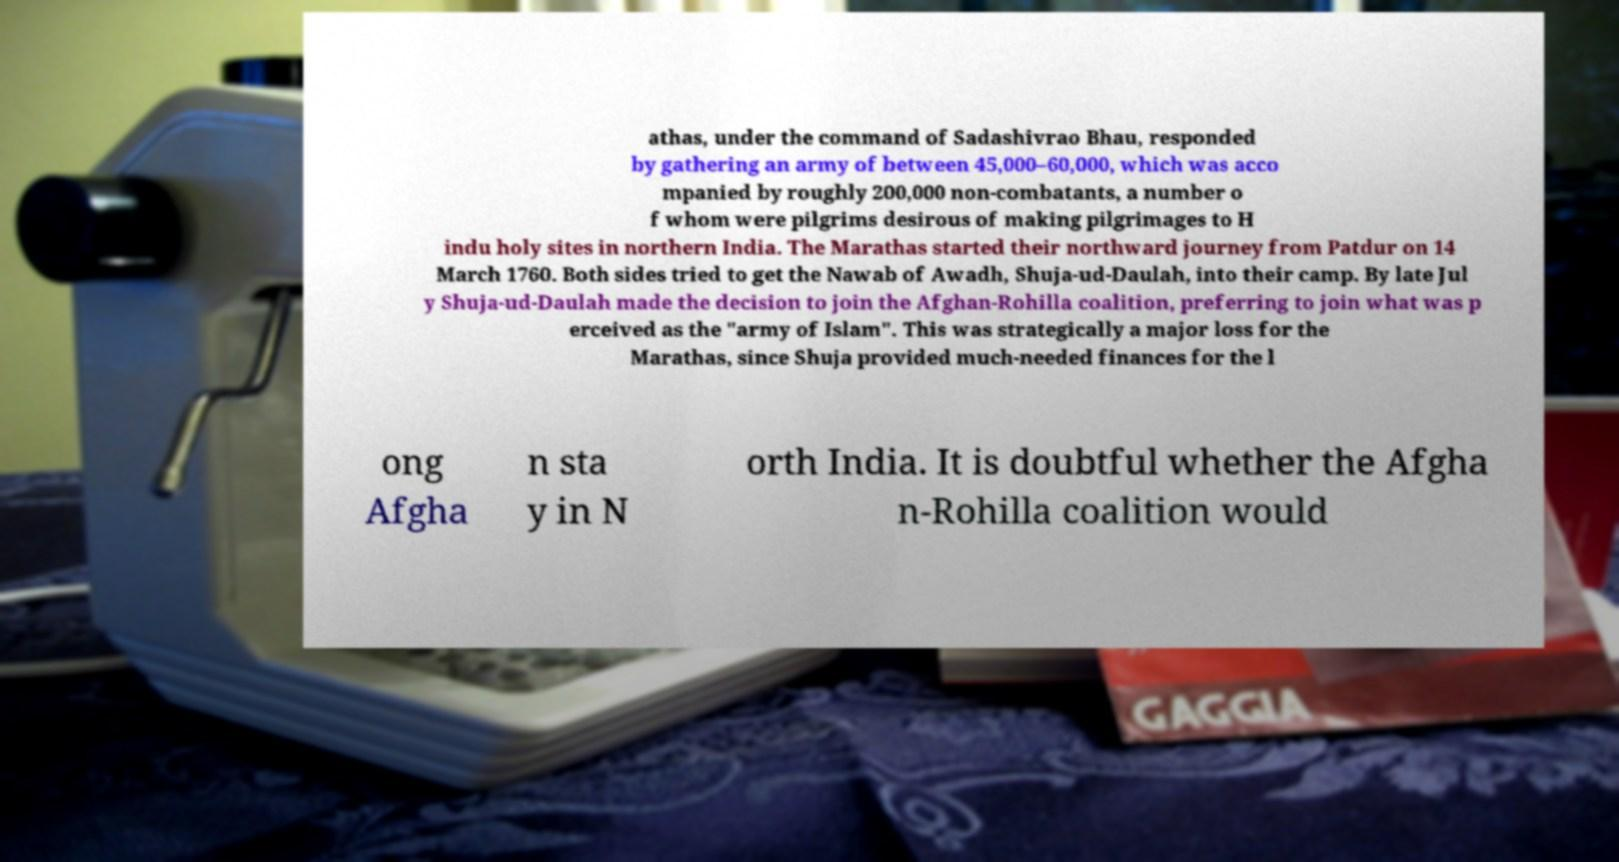Can you accurately transcribe the text from the provided image for me? athas, under the command of Sadashivrao Bhau, responded by gathering an army of between 45,000–60,000, which was acco mpanied by roughly 200,000 non-combatants, a number o f whom were pilgrims desirous of making pilgrimages to H indu holy sites in northern India. The Marathas started their northward journey from Patdur on 14 March 1760. Both sides tried to get the Nawab of Awadh, Shuja-ud-Daulah, into their camp. By late Jul y Shuja-ud-Daulah made the decision to join the Afghan-Rohilla coalition, preferring to join what was p erceived as the "army of Islam". This was strategically a major loss for the Marathas, since Shuja provided much-needed finances for the l ong Afgha n sta y in N orth India. It is doubtful whether the Afgha n-Rohilla coalition would 